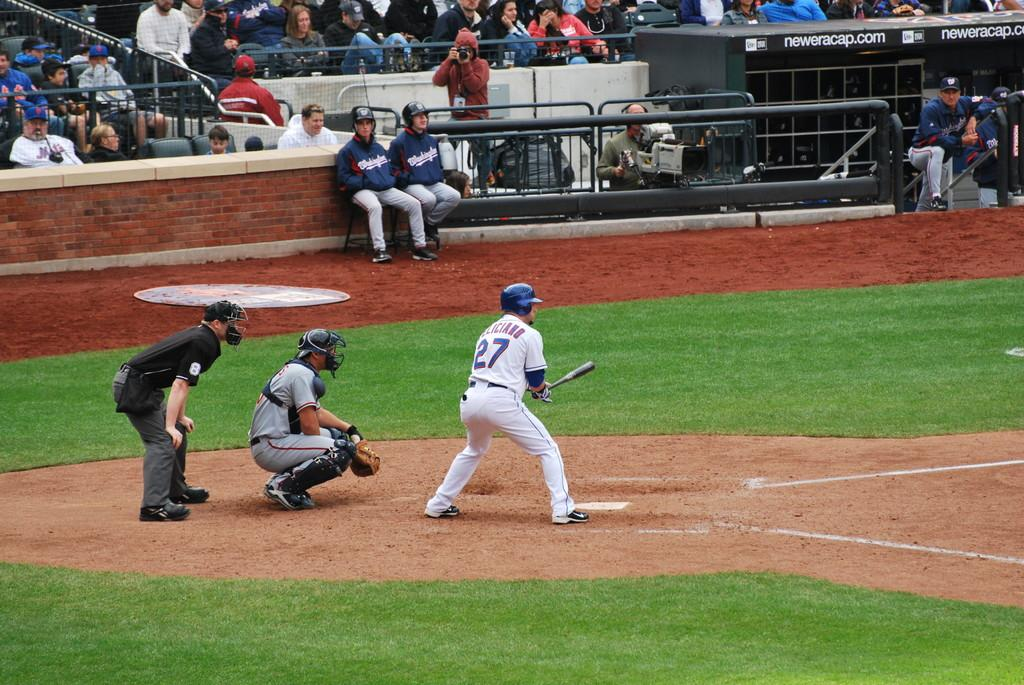Provide a one-sentence caption for the provided image. A baseball game is being played with number twenty seven up to bat. 